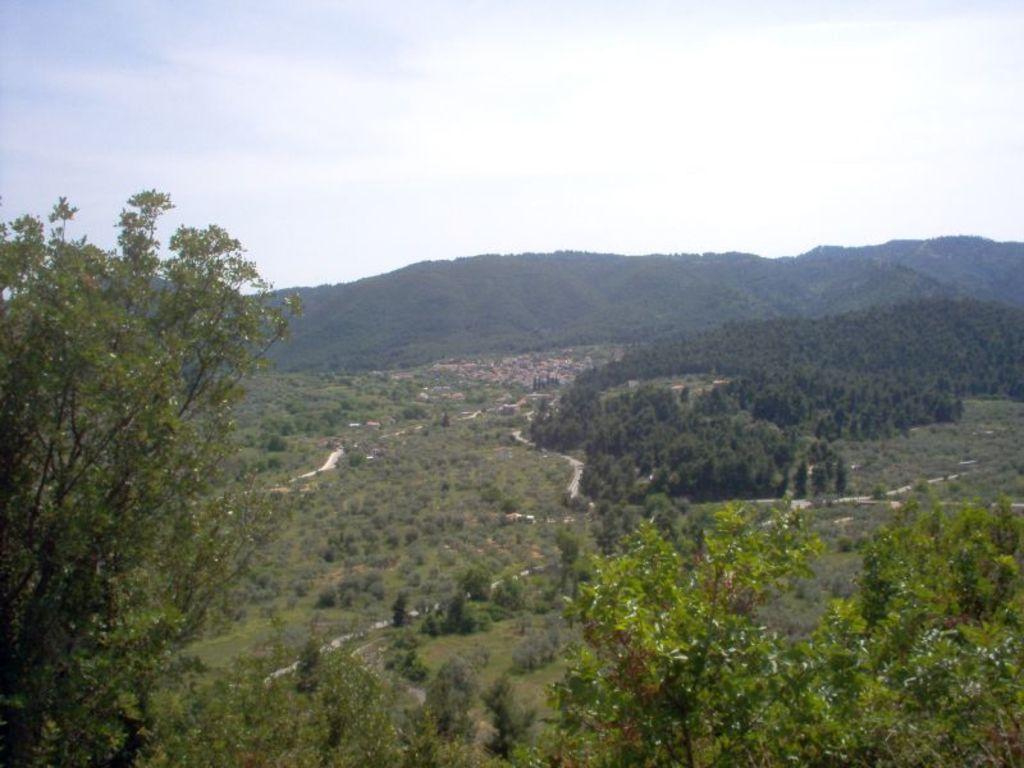Describe this image in one or two sentences. In this image I can see trees, grass and mountains. On the top I can see the sky. This image is taken may be in the forest. 